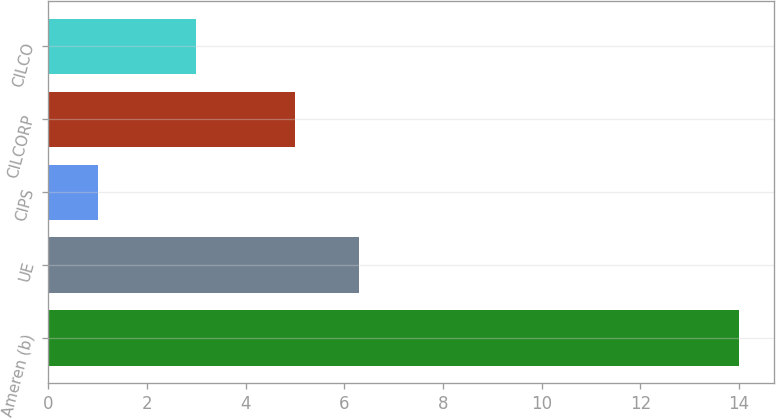<chart> <loc_0><loc_0><loc_500><loc_500><bar_chart><fcel>Ameren (b)<fcel>UE<fcel>CIPS<fcel>CILCORP<fcel>CILCO<nl><fcel>14<fcel>6.3<fcel>1<fcel>5<fcel>3<nl></chart> 